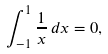Convert formula to latex. <formula><loc_0><loc_0><loc_500><loc_500>\int _ { - 1 } ^ { 1 } { \frac { 1 } { x } } \, d x = 0 ,</formula> 